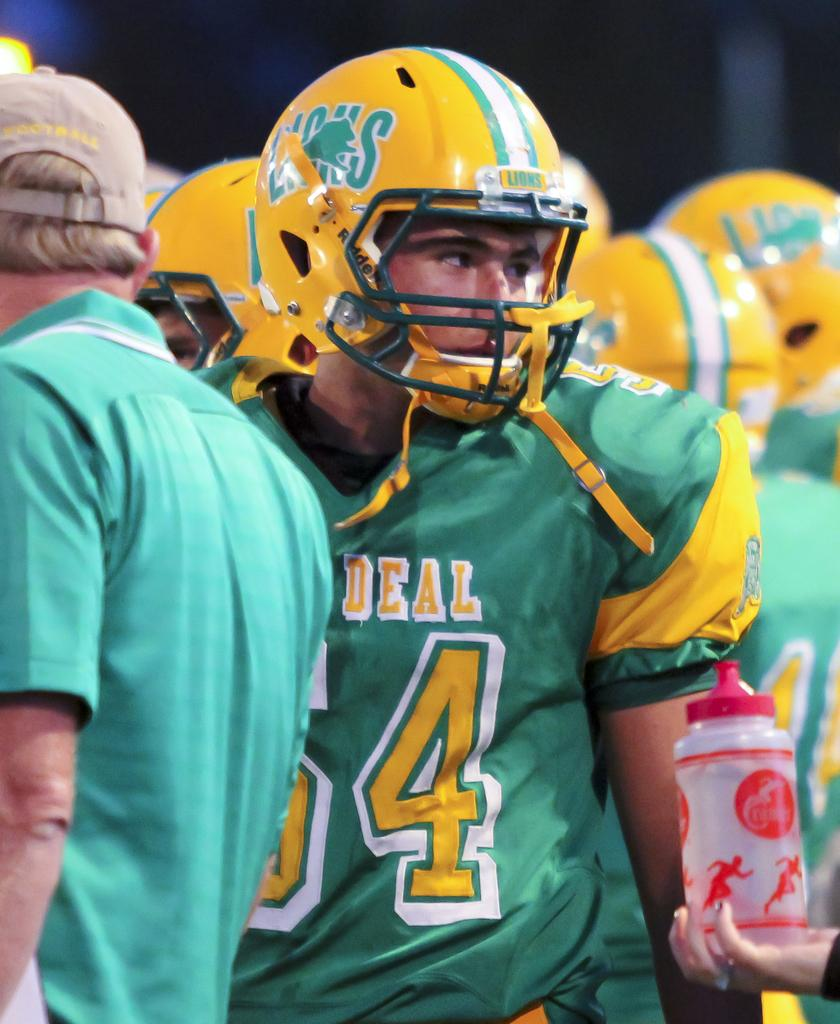How many people are in the image? There is a group of persons in the image. What are the people in the image doing? The persons are standing. What are the people wearing on their heads? The persons are wearing helmets. What color are the helmets? The helmets are yellow in color. What is the person on the right side holding? The person on the right side is holding a bottle. What is the opinion of the potato in the image? There is no potato present in the image, so it is not possible to determine its opinion. 